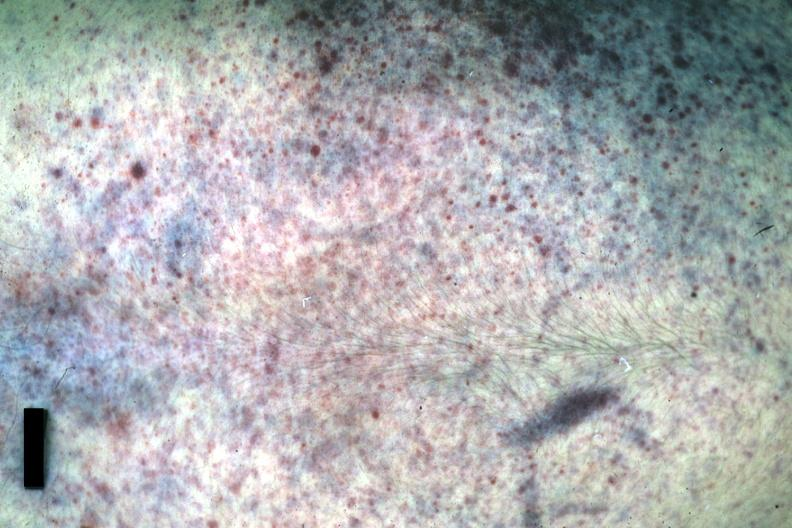does this image show good example either chest was anterior or posterior?
Answer the question using a single word or phrase. Yes 